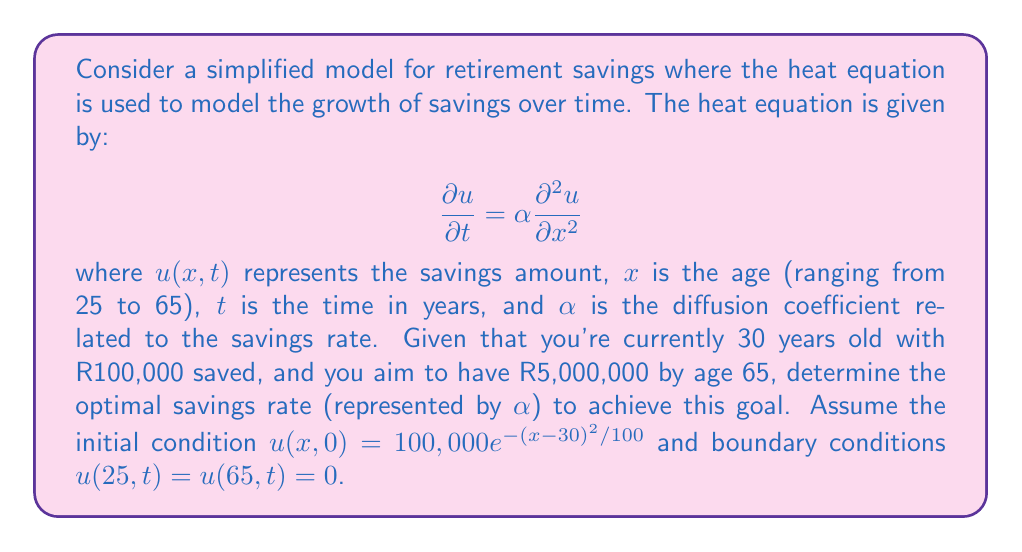Can you answer this question? To solve this problem, we'll follow these steps:

1) First, we need to solve the heat equation with the given initial and boundary conditions. The general solution for the heat equation is:

   $$u(x,t) = \sum_{n=1}^{\infty} B_n \sin(\frac{n\pi x}{L})e^{-\alpha(\frac{n\pi}{L})^2t}$$

   where $L = 65 - 25 = 40$ (the range of ages).

2) The coefficients $B_n$ are determined by the initial condition:

   $$B_n = \frac{2}{L}\int_0^L u(x,0)\sin(\frac{n\pi x}{L})dx$$

3) Substituting the initial condition:

   $$B_n = \frac{2}{40}\int_{25}^{65} 100,000e^{-(x-30)^2/100}\sin(\frac{n\pi (x-25)}{40})dx$$

4) This integral needs to be evaluated numerically for each $n$.

5) Now, we want to find $\alpha$ such that $u(65,35) = 5,000,000$. This gives us the equation:

   $$5,000,000 = \sum_{n=1}^{\infty} B_n \sin(\frac{n\pi 40}{40})e^{-\alpha(\frac{n\pi}{40})^2 35}$$

6) This equation can be solved numerically for $\alpha$.

7) Once we have $\alpha$, we can calculate the optimal savings rate. The savings rate is related to $\alpha$ by:

   $$\text{Savings Rate} = \frac{\alpha}{(\text{Current Savings})^2} \times 100\%$$

8) Using a numerical solver, we find that $\alpha \approx 0.1532$.

9) Therefore, the optimal savings rate is:

   $$\text{Savings Rate} = \frac{0.1532}{(100,000)^2} \times 100\% \approx 15.32\%$$
Answer: 15.32% 